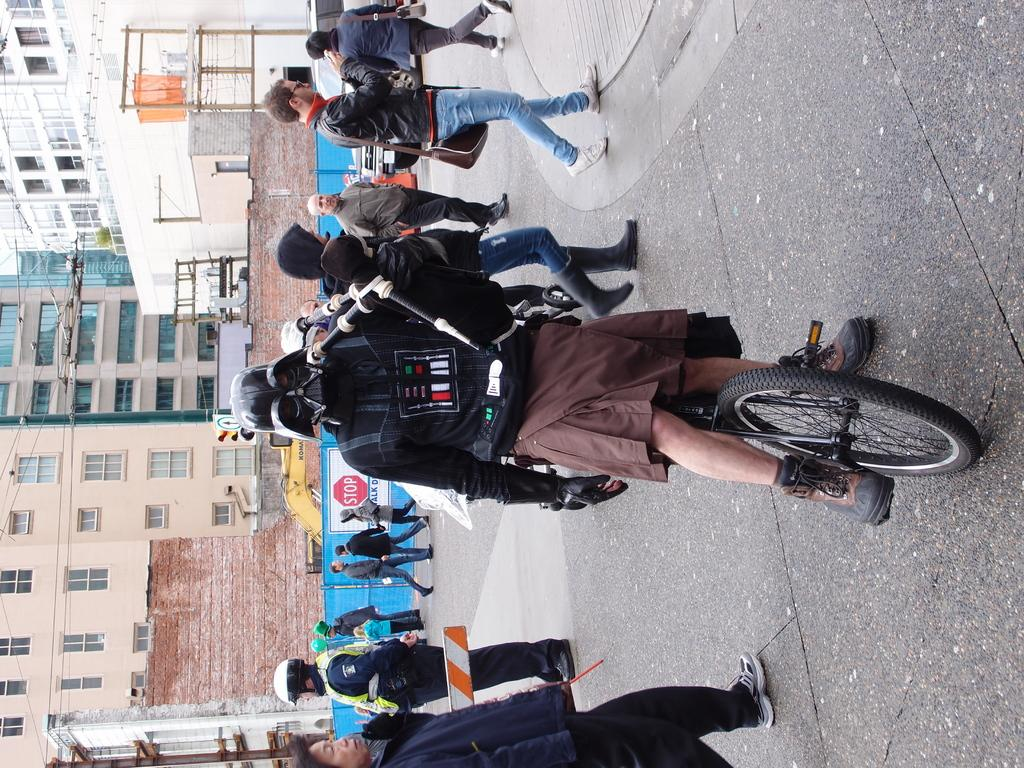How many people can be seen in the image? There is a group of people in the image. What else is present in the image besides the people? There are vehicles, buildings, electric poles, and cables visible in the image. Can you describe the vehicles in the image? The specific types of vehicles are not mentioned, but they are present in the image. What might the electric poles and cables be used for? The electric poles and cables are likely used for providing electricity to the area. What type of meat is being served on the board in the image? There is no board or meat present in the image. 